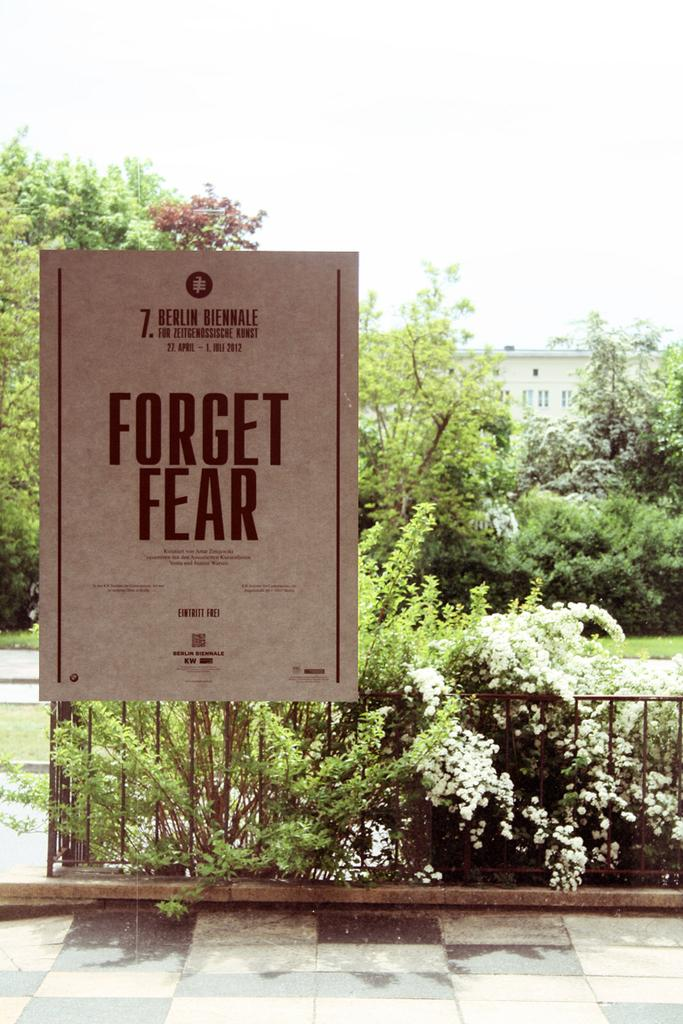What is written or displayed on the board in the image? There is a board with text in the image, but the specific content of the text is not mentioned in the facts. What type of vegetation can be seen in the image? There are plants, grass, and a group of trees in the image. What architectural feature is present in the image? There is a fence in the image. What type of structure is visible in the image? There is a building with windows in the image. What part of the natural environment is visible in the image? The sky is visible in the image. What type of drug is being sold by the fireman in the image? There is no fireman or drug present in the image. What type of sail can be seen on the boat in the image? There is no boat or sail present in the image. 